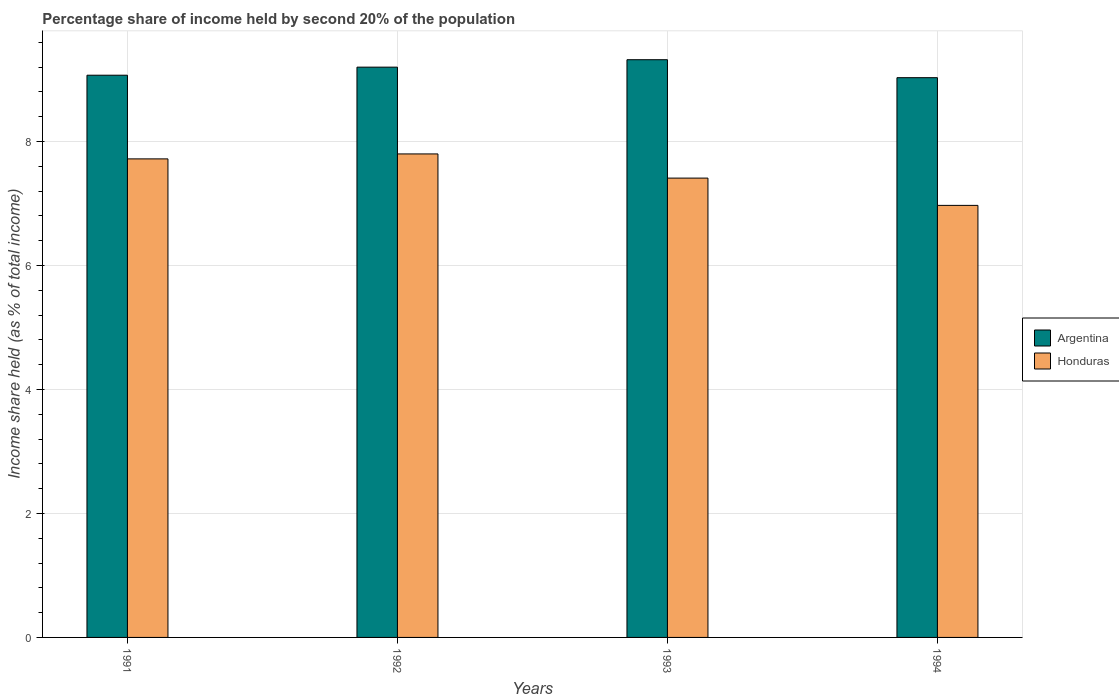Are the number of bars per tick equal to the number of legend labels?
Ensure brevity in your answer.  Yes. How many bars are there on the 1st tick from the right?
Offer a terse response. 2. What is the label of the 2nd group of bars from the left?
Keep it short and to the point. 1992. What is the share of income held by second 20% of the population in Argentina in 1993?
Provide a succinct answer. 9.32. Across all years, what is the minimum share of income held by second 20% of the population in Honduras?
Your response must be concise. 6.97. What is the total share of income held by second 20% of the population in Honduras in the graph?
Give a very brief answer. 29.9. What is the difference between the share of income held by second 20% of the population in Argentina in 1992 and that in 1993?
Your answer should be very brief. -0.12. What is the difference between the share of income held by second 20% of the population in Honduras in 1992 and the share of income held by second 20% of the population in Argentina in 1991?
Provide a succinct answer. -1.27. What is the average share of income held by second 20% of the population in Honduras per year?
Ensure brevity in your answer.  7.47. In the year 1994, what is the difference between the share of income held by second 20% of the population in Argentina and share of income held by second 20% of the population in Honduras?
Your answer should be very brief. 2.06. What is the ratio of the share of income held by second 20% of the population in Honduras in 1991 to that in 1992?
Your answer should be compact. 0.99. Is the share of income held by second 20% of the population in Argentina in 1991 less than that in 1994?
Your response must be concise. No. What is the difference between the highest and the second highest share of income held by second 20% of the population in Argentina?
Provide a short and direct response. 0.12. What is the difference between the highest and the lowest share of income held by second 20% of the population in Honduras?
Offer a terse response. 0.83. In how many years, is the share of income held by second 20% of the population in Argentina greater than the average share of income held by second 20% of the population in Argentina taken over all years?
Ensure brevity in your answer.  2. What does the 2nd bar from the left in 1992 represents?
Give a very brief answer. Honduras. What does the 1st bar from the right in 1994 represents?
Make the answer very short. Honduras. How many bars are there?
Keep it short and to the point. 8. Does the graph contain grids?
Provide a short and direct response. Yes. How are the legend labels stacked?
Offer a terse response. Vertical. What is the title of the graph?
Keep it short and to the point. Percentage share of income held by second 20% of the population. What is the label or title of the Y-axis?
Make the answer very short. Income share held (as % of total income). What is the Income share held (as % of total income) in Argentina in 1991?
Ensure brevity in your answer.  9.07. What is the Income share held (as % of total income) in Honduras in 1991?
Give a very brief answer. 7.72. What is the Income share held (as % of total income) of Argentina in 1992?
Offer a very short reply. 9.2. What is the Income share held (as % of total income) of Honduras in 1992?
Make the answer very short. 7.8. What is the Income share held (as % of total income) of Argentina in 1993?
Your answer should be very brief. 9.32. What is the Income share held (as % of total income) of Honduras in 1993?
Keep it short and to the point. 7.41. What is the Income share held (as % of total income) of Argentina in 1994?
Offer a terse response. 9.03. What is the Income share held (as % of total income) of Honduras in 1994?
Ensure brevity in your answer.  6.97. Across all years, what is the maximum Income share held (as % of total income) of Argentina?
Provide a succinct answer. 9.32. Across all years, what is the minimum Income share held (as % of total income) in Argentina?
Give a very brief answer. 9.03. Across all years, what is the minimum Income share held (as % of total income) of Honduras?
Offer a very short reply. 6.97. What is the total Income share held (as % of total income) of Argentina in the graph?
Offer a terse response. 36.62. What is the total Income share held (as % of total income) in Honduras in the graph?
Your answer should be very brief. 29.9. What is the difference between the Income share held (as % of total income) in Argentina in 1991 and that in 1992?
Ensure brevity in your answer.  -0.13. What is the difference between the Income share held (as % of total income) of Honduras in 1991 and that in 1992?
Your response must be concise. -0.08. What is the difference between the Income share held (as % of total income) of Honduras in 1991 and that in 1993?
Provide a succinct answer. 0.31. What is the difference between the Income share held (as % of total income) of Argentina in 1991 and that in 1994?
Your response must be concise. 0.04. What is the difference between the Income share held (as % of total income) of Argentina in 1992 and that in 1993?
Offer a very short reply. -0.12. What is the difference between the Income share held (as % of total income) in Honduras in 1992 and that in 1993?
Offer a very short reply. 0.39. What is the difference between the Income share held (as % of total income) of Argentina in 1992 and that in 1994?
Make the answer very short. 0.17. What is the difference between the Income share held (as % of total income) of Honduras in 1992 and that in 1994?
Offer a very short reply. 0.83. What is the difference between the Income share held (as % of total income) in Argentina in 1993 and that in 1994?
Provide a succinct answer. 0.29. What is the difference between the Income share held (as % of total income) in Honduras in 1993 and that in 1994?
Ensure brevity in your answer.  0.44. What is the difference between the Income share held (as % of total income) in Argentina in 1991 and the Income share held (as % of total income) in Honduras in 1992?
Your response must be concise. 1.27. What is the difference between the Income share held (as % of total income) of Argentina in 1991 and the Income share held (as % of total income) of Honduras in 1993?
Make the answer very short. 1.66. What is the difference between the Income share held (as % of total income) of Argentina in 1992 and the Income share held (as % of total income) of Honduras in 1993?
Keep it short and to the point. 1.79. What is the difference between the Income share held (as % of total income) in Argentina in 1992 and the Income share held (as % of total income) in Honduras in 1994?
Offer a terse response. 2.23. What is the difference between the Income share held (as % of total income) of Argentina in 1993 and the Income share held (as % of total income) of Honduras in 1994?
Your response must be concise. 2.35. What is the average Income share held (as % of total income) of Argentina per year?
Your answer should be compact. 9.15. What is the average Income share held (as % of total income) of Honduras per year?
Give a very brief answer. 7.47. In the year 1991, what is the difference between the Income share held (as % of total income) of Argentina and Income share held (as % of total income) of Honduras?
Offer a very short reply. 1.35. In the year 1993, what is the difference between the Income share held (as % of total income) of Argentina and Income share held (as % of total income) of Honduras?
Ensure brevity in your answer.  1.91. In the year 1994, what is the difference between the Income share held (as % of total income) of Argentina and Income share held (as % of total income) of Honduras?
Provide a succinct answer. 2.06. What is the ratio of the Income share held (as % of total income) of Argentina in 1991 to that in 1992?
Provide a short and direct response. 0.99. What is the ratio of the Income share held (as % of total income) of Argentina in 1991 to that in 1993?
Your answer should be compact. 0.97. What is the ratio of the Income share held (as % of total income) in Honduras in 1991 to that in 1993?
Your response must be concise. 1.04. What is the ratio of the Income share held (as % of total income) in Argentina in 1991 to that in 1994?
Offer a very short reply. 1. What is the ratio of the Income share held (as % of total income) in Honduras in 1991 to that in 1994?
Your answer should be compact. 1.11. What is the ratio of the Income share held (as % of total income) of Argentina in 1992 to that in 1993?
Keep it short and to the point. 0.99. What is the ratio of the Income share held (as % of total income) in Honduras in 1992 to that in 1993?
Offer a terse response. 1.05. What is the ratio of the Income share held (as % of total income) of Argentina in 1992 to that in 1994?
Keep it short and to the point. 1.02. What is the ratio of the Income share held (as % of total income) of Honduras in 1992 to that in 1994?
Your response must be concise. 1.12. What is the ratio of the Income share held (as % of total income) of Argentina in 1993 to that in 1994?
Provide a succinct answer. 1.03. What is the ratio of the Income share held (as % of total income) of Honduras in 1993 to that in 1994?
Offer a terse response. 1.06. What is the difference between the highest and the second highest Income share held (as % of total income) of Argentina?
Give a very brief answer. 0.12. What is the difference between the highest and the lowest Income share held (as % of total income) in Argentina?
Ensure brevity in your answer.  0.29. What is the difference between the highest and the lowest Income share held (as % of total income) of Honduras?
Give a very brief answer. 0.83. 